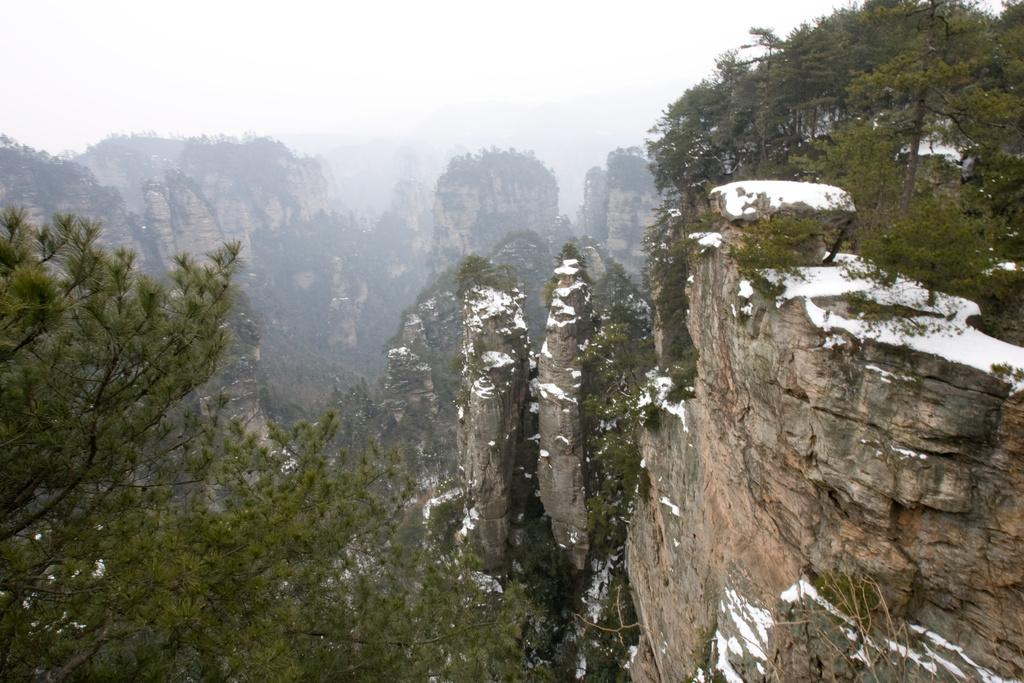What type of natural formation can be seen in the image? There are mountains in the image. What type of vegetation is present in the image? There are trees in the image. What is covering the mountains in the image? There is snow on the mountains. What is visible in the background of the image? The sky is visible in the background of the image. Where are the ants fighting in the image? There are no ants or fighting present in the image. 